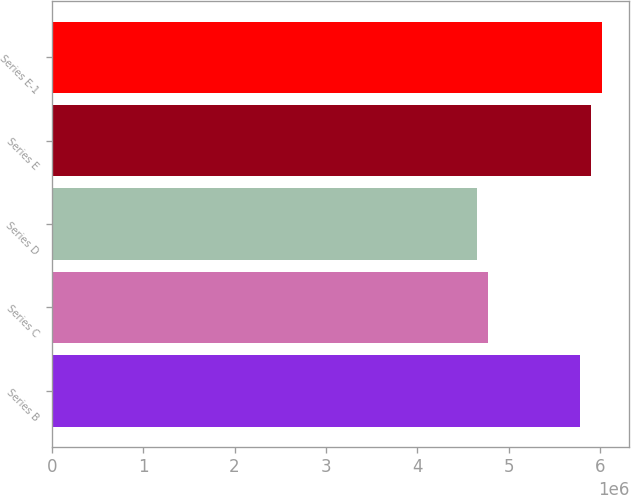Convert chart. <chart><loc_0><loc_0><loc_500><loc_500><bar_chart><fcel>Series B<fcel>Series C<fcel>Series D<fcel>Series E<fcel>Series E-1<nl><fcel>5.77662e+06<fcel>4.77242e+06<fcel>4.65e+06<fcel>5.89904e+06<fcel>6.02146e+06<nl></chart> 